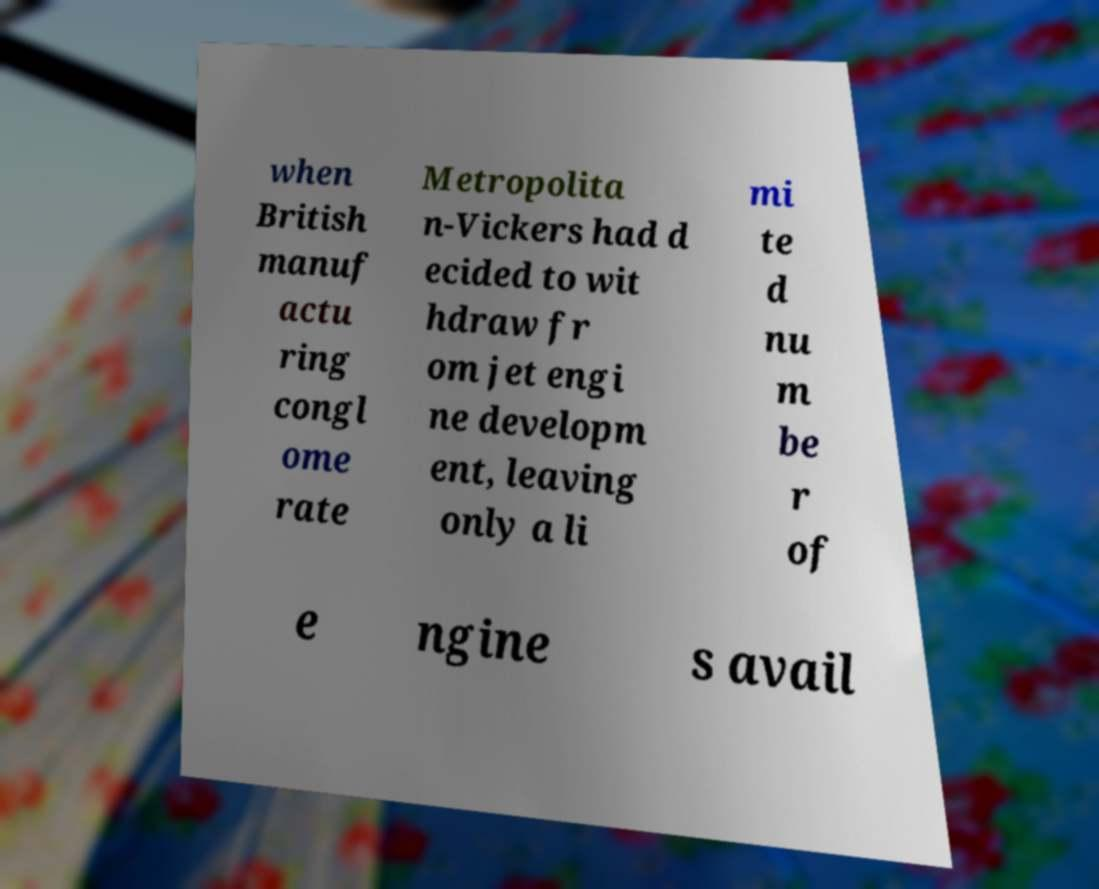Please read and relay the text visible in this image. What does it say? when British manuf actu ring congl ome rate Metropolita n-Vickers had d ecided to wit hdraw fr om jet engi ne developm ent, leaving only a li mi te d nu m be r of e ngine s avail 